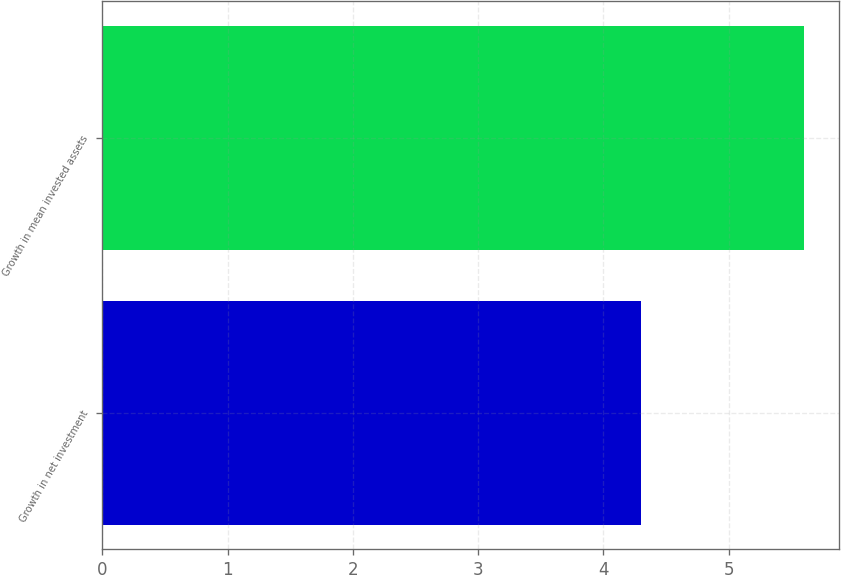<chart> <loc_0><loc_0><loc_500><loc_500><bar_chart><fcel>Growth in net investment<fcel>Growth in mean invested assets<nl><fcel>4.3<fcel>5.6<nl></chart> 